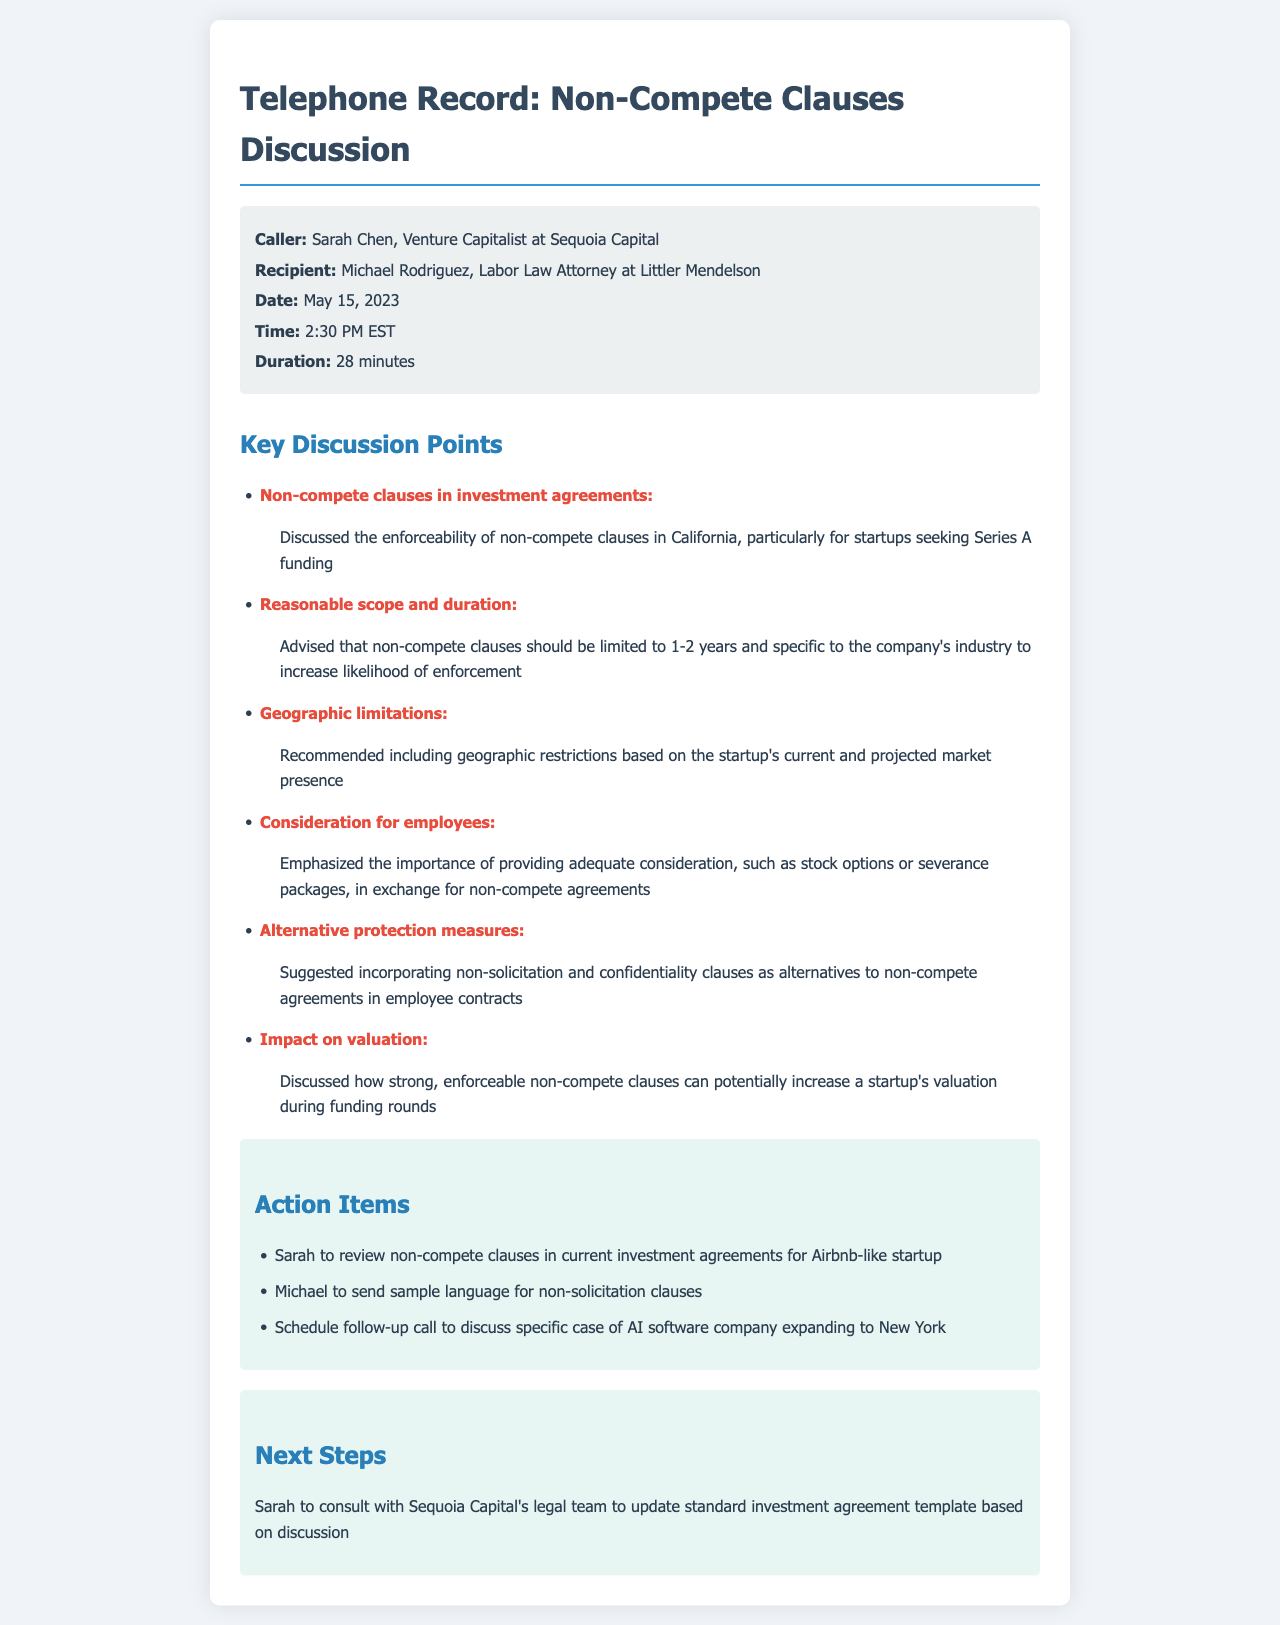What is the name of the caller? The caller is identified as Sarah Chen, Venture Capitalist at Sequoia Capital.
Answer: Sarah Chen Who is the recipient of the call? The recipient is mentioned as Michael Rodriguez, Labor Law Attorney at Littler Mendelson.
Answer: Michael Rodriguez What was the date of the call? The document states the date of the call was May 15, 2023.
Answer: May 15, 2023 How long did the call last? The duration of the call is stated as 28 minutes.
Answer: 28 minutes What is one key topic discussed regarding non-compete clauses? The discussion included the enforceability of non-compete clauses in California for startups seeking Series A funding.
Answer: Enforceability in California What is a recommendation for the duration of non-compete clauses? The advice given was that non-compete clauses should be limited to 1-2 years.
Answer: 1-2 years What is one alternative to non-compete agreements mentioned? The document suggests incorporating non-solicitation clauses as an alternative.
Answer: Non-solicitation clauses What action item involves a review? One action item states that Sarah will review non-compete clauses in current investment agreements.
Answer: Review non-compete clauses What are the next steps outlined for Sarah? The next steps specify that Sarah will consult with Sequoia Capital's legal team.
Answer: Consult with legal team What industry context is provided for consideration in non-compete clauses? The discussion mentions that the non-compete clauses should be specific to the company's industry.
Answer: Specific to the company's industry 